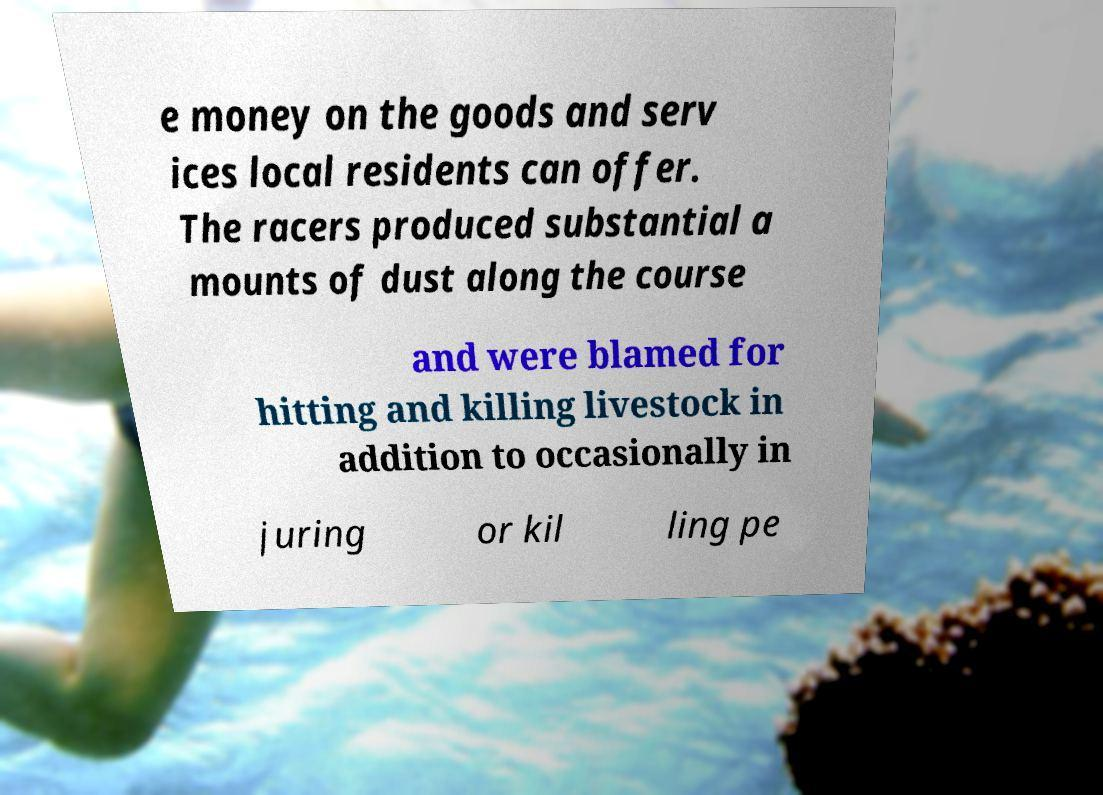Could you assist in decoding the text presented in this image and type it out clearly? e money on the goods and serv ices local residents can offer. The racers produced substantial a mounts of dust along the course and were blamed for hitting and killing livestock in addition to occasionally in juring or kil ling pe 